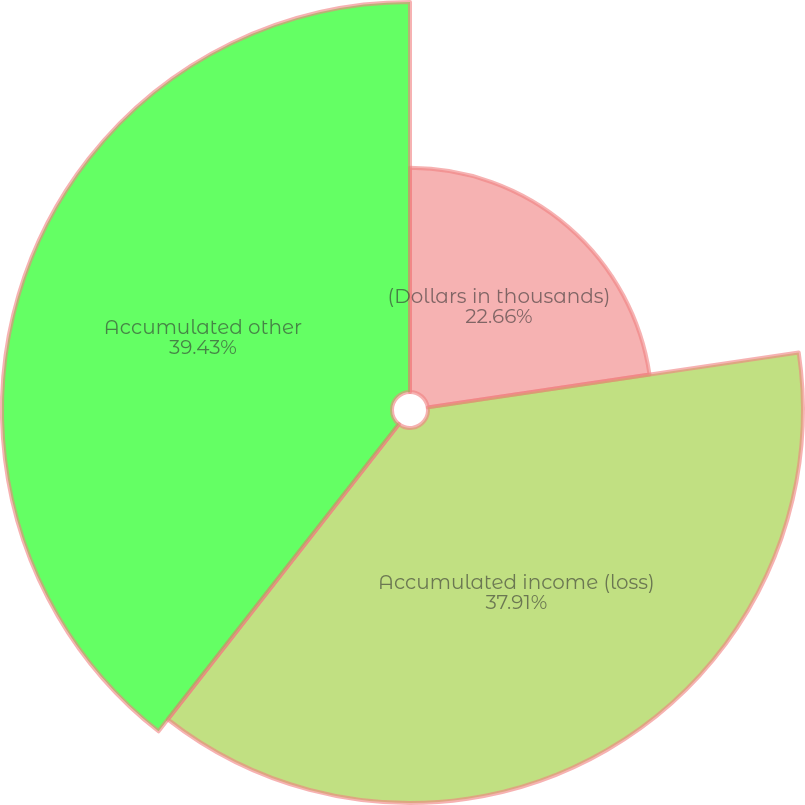Convert chart. <chart><loc_0><loc_0><loc_500><loc_500><pie_chart><fcel>(Dollars in thousands)<fcel>Accumulated income (loss)<fcel>Accumulated other<nl><fcel>22.66%<fcel>37.91%<fcel>39.43%<nl></chart> 